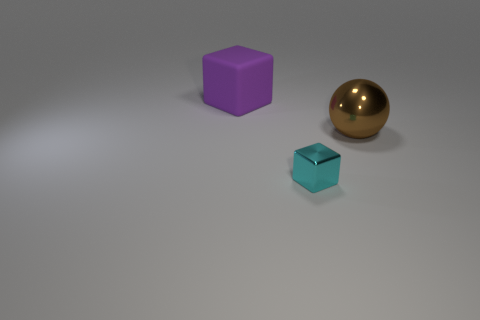Add 3 metal cubes. How many objects exist? 6 Subtract all blocks. How many objects are left? 1 Subtract all large purple metal objects. Subtract all cubes. How many objects are left? 1 Add 1 purple rubber blocks. How many purple rubber blocks are left? 2 Add 2 cubes. How many cubes exist? 4 Subtract 0 cyan cylinders. How many objects are left? 3 Subtract all yellow cubes. Subtract all yellow balls. How many cubes are left? 2 Subtract all blue spheres. How many purple blocks are left? 1 